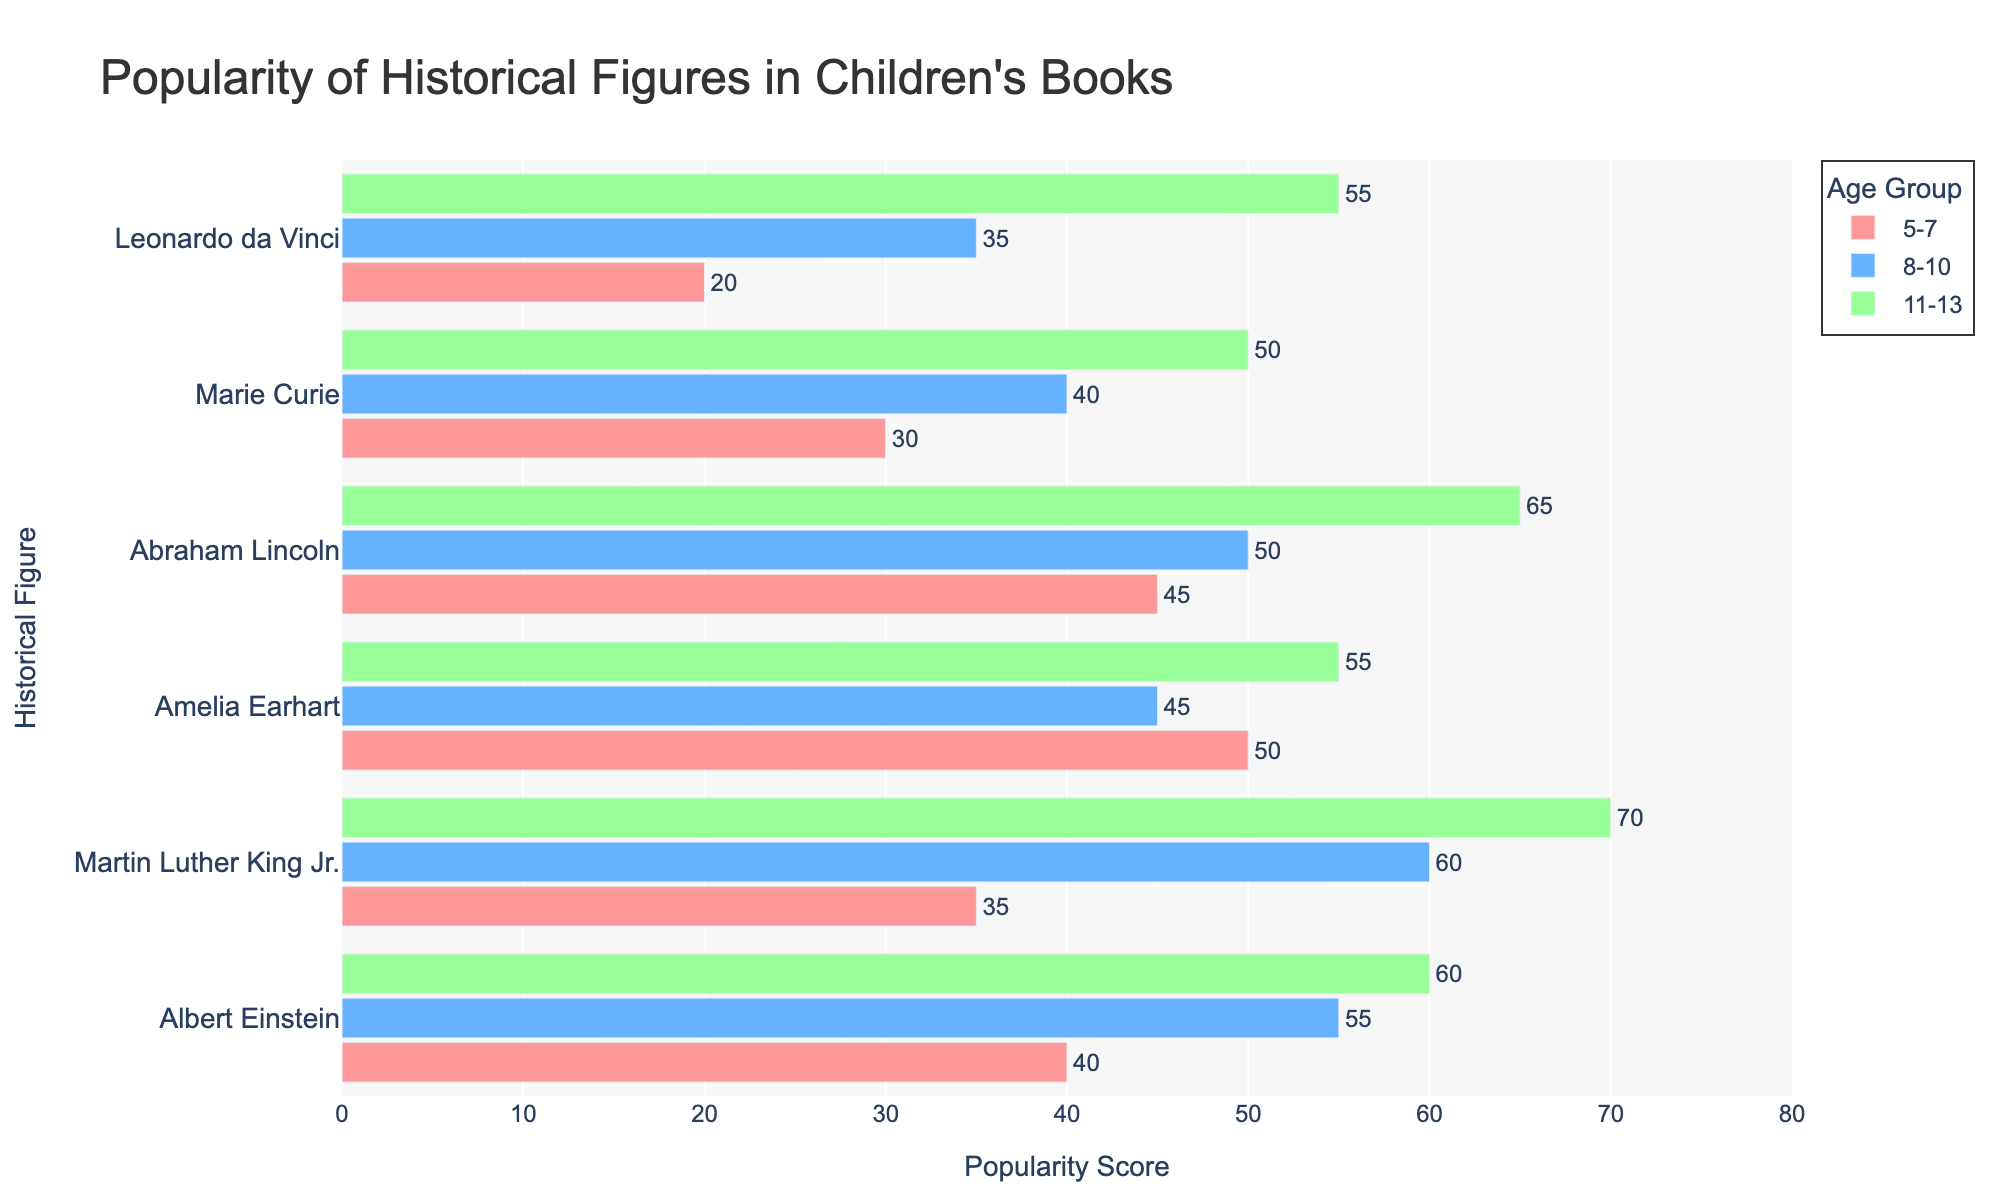Which historical figure is the most popular among the 5-7 age group? Look at the bars for the 5-7 age group and find the one with the highest popularity score. Amelia Earhart's bar is the highest.
Answer: Amelia Earhart Which age group shows a higher popularity score for Martin Luther King Jr., 8-10 or 11-13? Compare the height of the bars for Martin Luther King Jr. for age groups 8-10 and 11-13. The bar is higher for the 11-13 age group.
Answer: 11-13 What is the combined popularity score of Albert Einstein across all age groups? Add the popularity scores of Albert Einstein for all age groups: 40 (5-7) + 55 (8-10) + 60 (11-13) = 155.
Answer: 155 Who has a higher popularity score among the 11-13 age group, Amelia Earhart or Leonardo da Vinci? Look at the bars for Amelia Earhart and Leonardo da Vinci in the 11-13 age group. Amelia Earhart's bar is slightly lower than Leonardo da Vinci's.
Answer: Leonardo da Vinci Which historical figure shows the largest increase in popularity score from the 5-7 age group to the 8-10 age group? Calculate the difference in popularity score for each historical figure between the 5-7 and 8-10 age groups. Albert Einstein shows an increase of 55 - 40 = 15. Abraham Lincoln shows an increase of 50 - 45 = 5. Marie Curie shows an increase of 40 - 30 = 10. Leonardo da Vinci shows an increase of 35 - 20 = 15. Martin Luther King Jr. shows an increase of 60 - 35 = 25. The largest increase is for Martin Luther King Jr.
Answer: Martin Luther King Jr Which historical figure is least popular among the 8-10 age group? Find the smallest bar in the 8-10 age group. Leonardo da Vinci's bar is the shortest at 35.
Answer: Leonardo da Vinci Is the average popularity score of Abraham Lincoln across all age groups greater than 50? Calculate the average popularity score for Abraham Lincoln: (45 + 50 + 65) / 3 = 160 / 3 ≈ 53.33. Since 53.33 is greater than 50, the answer is yes.
Answer: Yes What is the total popularity score of all historical figures for the 5-7 age group? Add the popularity scores of all historical figures in the 5-7 age group: 40 (Albert Einstein) + 35 (Martin Luther King Jr.) + 50 (Amelia Earhart) + 45 (Abraham Lincoln) + 30 (Marie Curie) + 20 (Leonardo da Vinci) = 220.
Answer: 220 Which historical figure shows a steady increase in popularity score across all age groups? Check the popularity scores for each historical figure across the 5-7, 8-10, and 11-13 age groups. Only Albert Einstein has scores that steadily increase: 40 (5-7), 55 (8-10), 60 (11-13).
Answer: Albert Einstein 